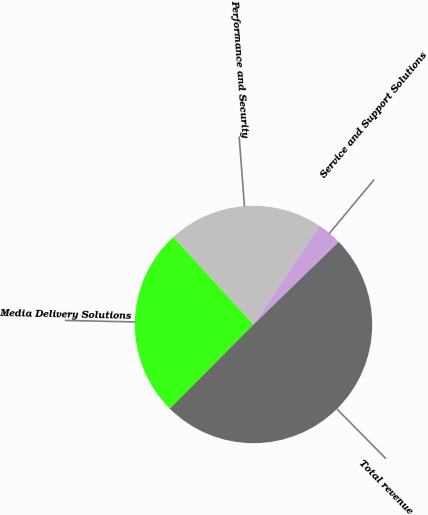Convert chart. <chart><loc_0><loc_0><loc_500><loc_500><pie_chart><fcel>Media Delivery Solutions<fcel>Performance and Security<fcel>Service and Support Solutions<fcel>Total revenue<nl><fcel>25.76%<fcel>21.13%<fcel>3.4%<fcel>49.72%<nl></chart> 